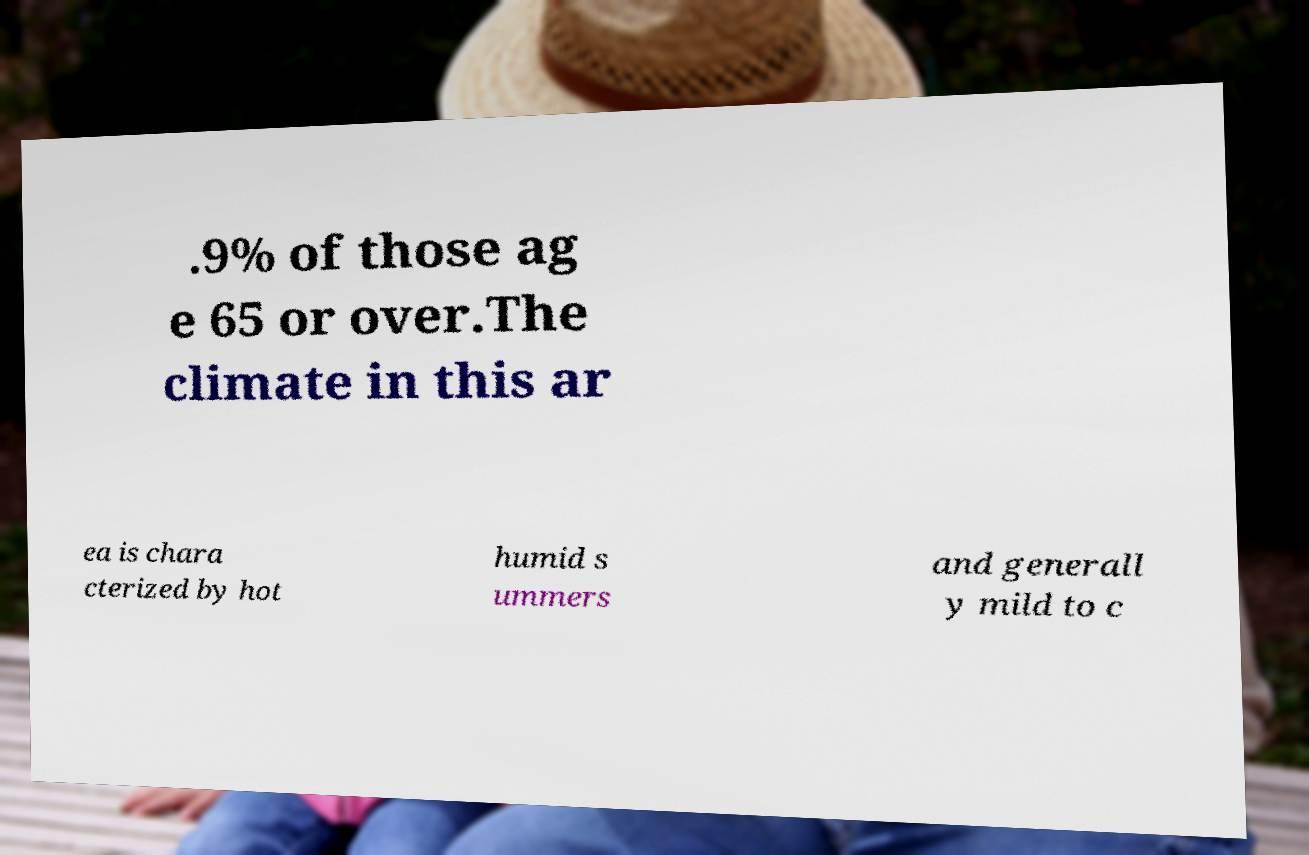Please read and relay the text visible in this image. What does it say? .9% of those ag e 65 or over.The climate in this ar ea is chara cterized by hot humid s ummers and generall y mild to c 